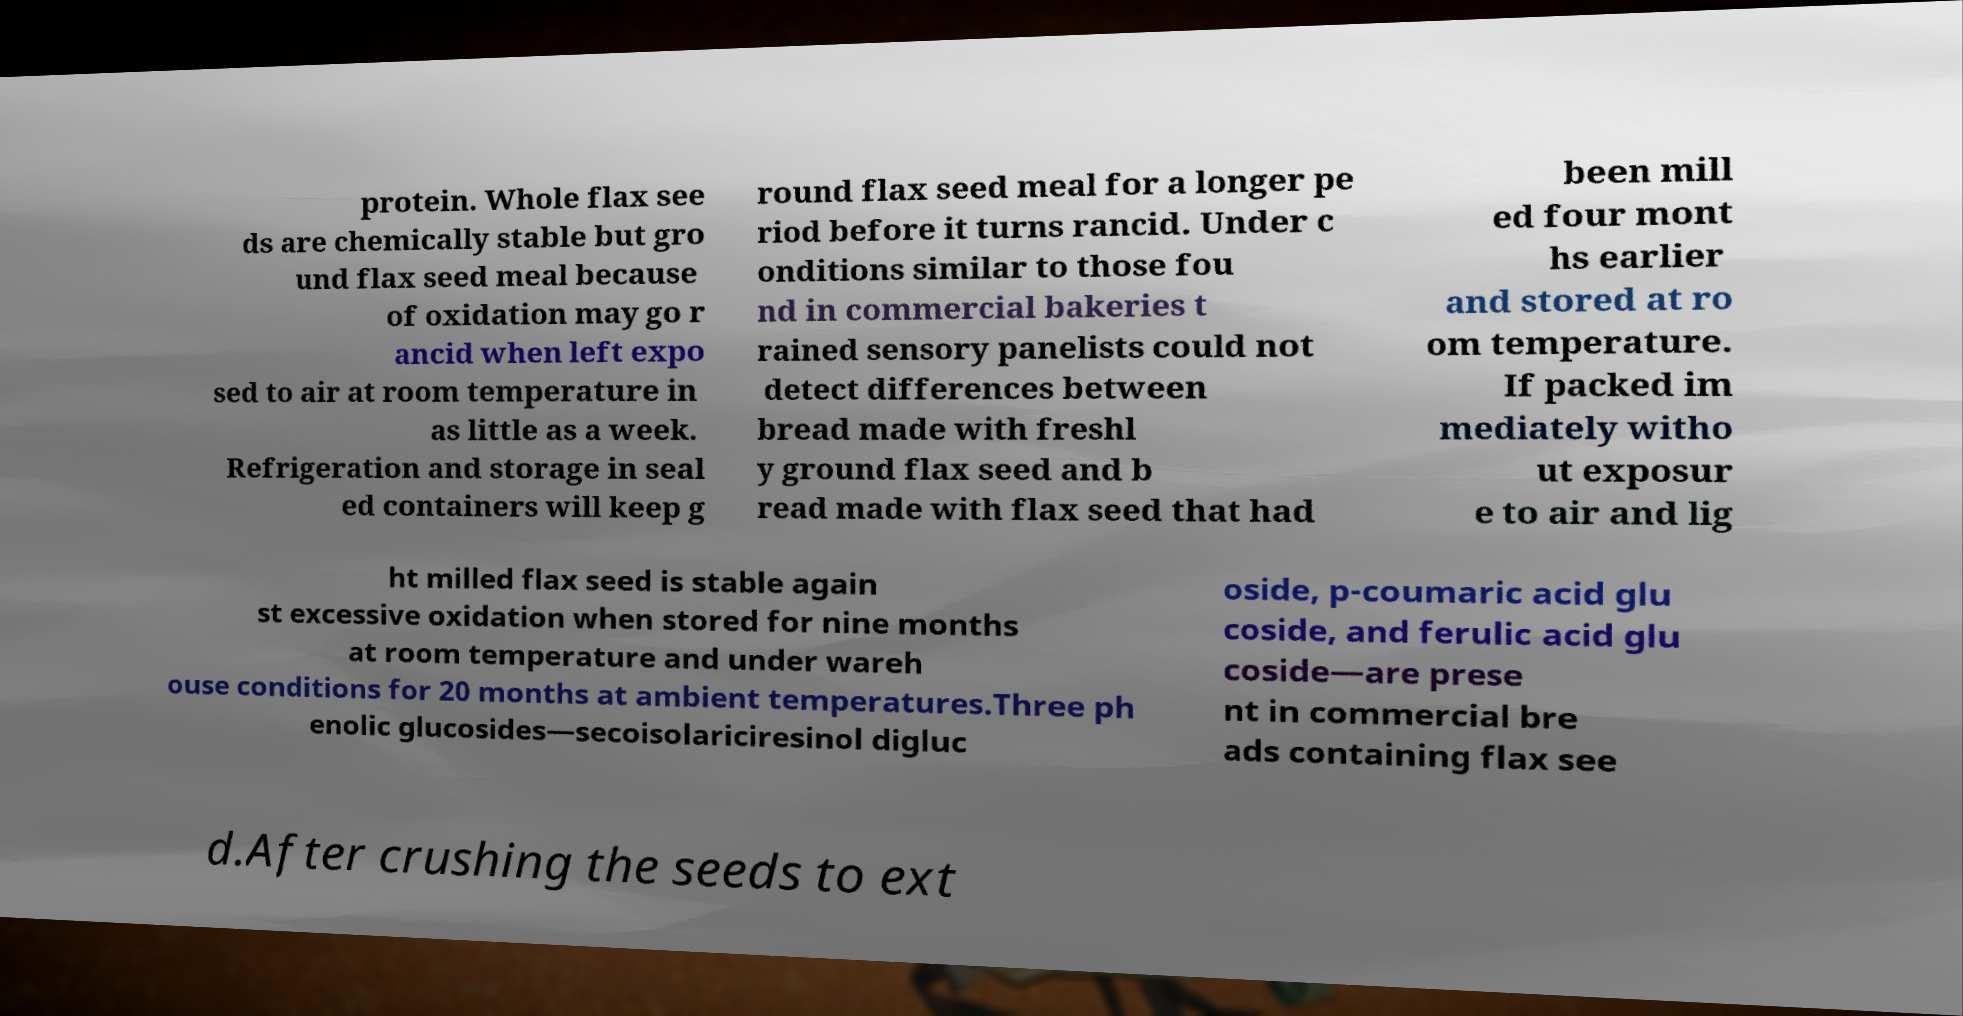Please identify and transcribe the text found in this image. protein. Whole flax see ds are chemically stable but gro und flax seed meal because of oxidation may go r ancid when left expo sed to air at room temperature in as little as a week. Refrigeration and storage in seal ed containers will keep g round flax seed meal for a longer pe riod before it turns rancid. Under c onditions similar to those fou nd in commercial bakeries t rained sensory panelists could not detect differences between bread made with freshl y ground flax seed and b read made with flax seed that had been mill ed four mont hs earlier and stored at ro om temperature. If packed im mediately witho ut exposur e to air and lig ht milled flax seed is stable again st excessive oxidation when stored for nine months at room temperature and under wareh ouse conditions for 20 months at ambient temperatures.Three ph enolic glucosides—secoisolariciresinol digluc oside, p-coumaric acid glu coside, and ferulic acid glu coside—are prese nt in commercial bre ads containing flax see d.After crushing the seeds to ext 